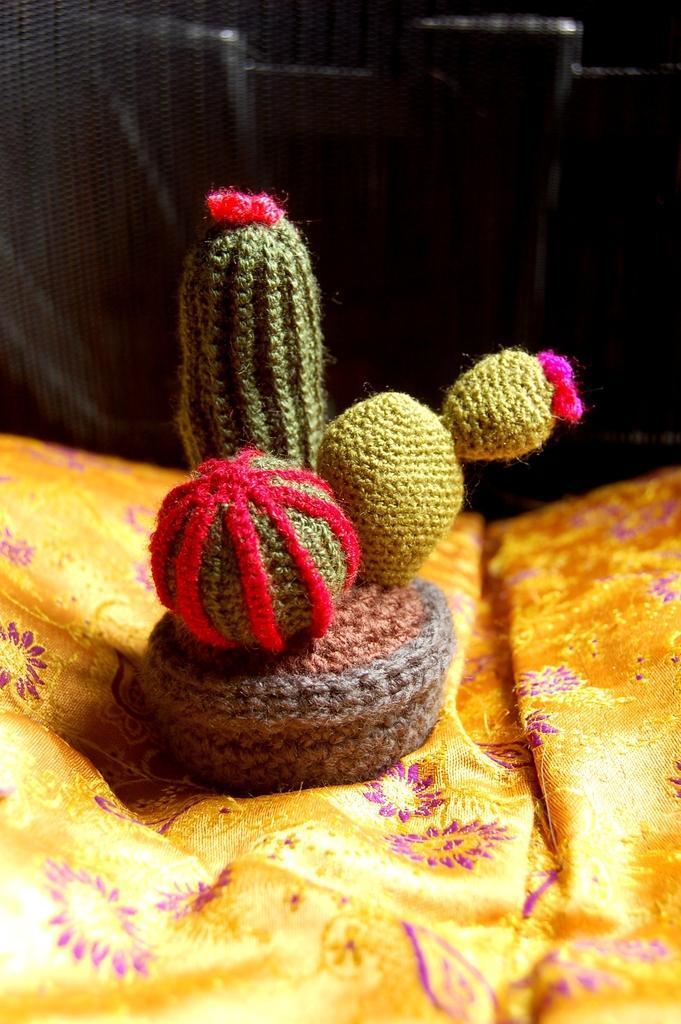Could you give a brief overview of what you see in this image? In this image I can see the woolen object on the yellow color cloth and the woolen object is in green, red and pink color and I can see the dark background. 